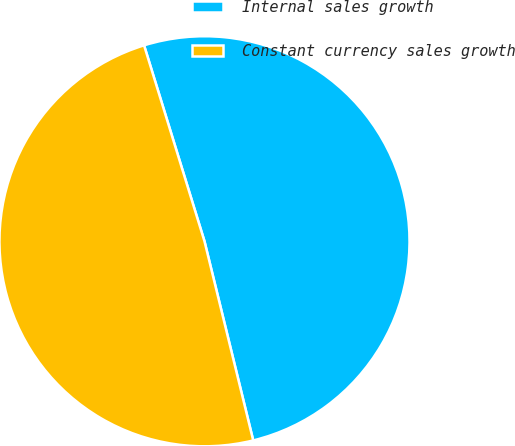<chart> <loc_0><loc_0><loc_500><loc_500><pie_chart><fcel>Internal sales growth<fcel>Constant currency sales growth<nl><fcel>50.94%<fcel>49.06%<nl></chart> 